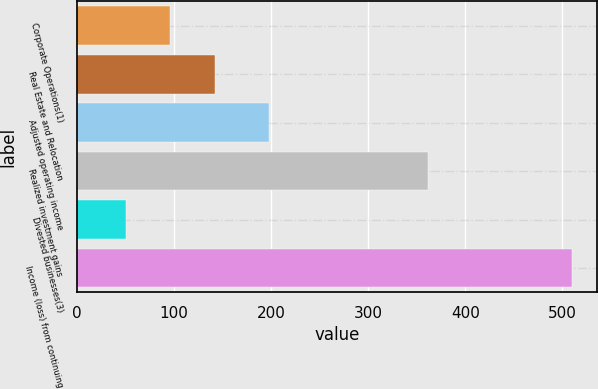<chart> <loc_0><loc_0><loc_500><loc_500><bar_chart><fcel>Corporate Operations(1)<fcel>Real Estate and Relocation<fcel>Adjusted operating income<fcel>Realized investment gains<fcel>Divested businesses(3)<fcel>Income (loss) from continuing<nl><fcel>96<fcel>142<fcel>198<fcel>362<fcel>50<fcel>510<nl></chart> 